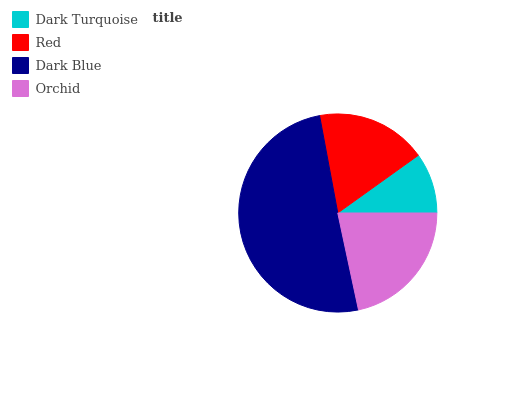Is Dark Turquoise the minimum?
Answer yes or no. Yes. Is Dark Blue the maximum?
Answer yes or no. Yes. Is Red the minimum?
Answer yes or no. No. Is Red the maximum?
Answer yes or no. No. Is Red greater than Dark Turquoise?
Answer yes or no. Yes. Is Dark Turquoise less than Red?
Answer yes or no. Yes. Is Dark Turquoise greater than Red?
Answer yes or no. No. Is Red less than Dark Turquoise?
Answer yes or no. No. Is Orchid the high median?
Answer yes or no. Yes. Is Red the low median?
Answer yes or no. Yes. Is Dark Blue the high median?
Answer yes or no. No. Is Dark Blue the low median?
Answer yes or no. No. 